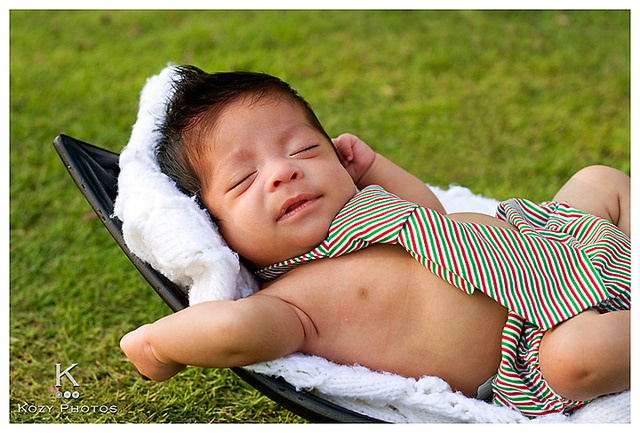Describe the objects in this image and their specific colors. I can see people in white, tan, and salmon tones and tie in white, red, green, and lightblue tones in this image. 